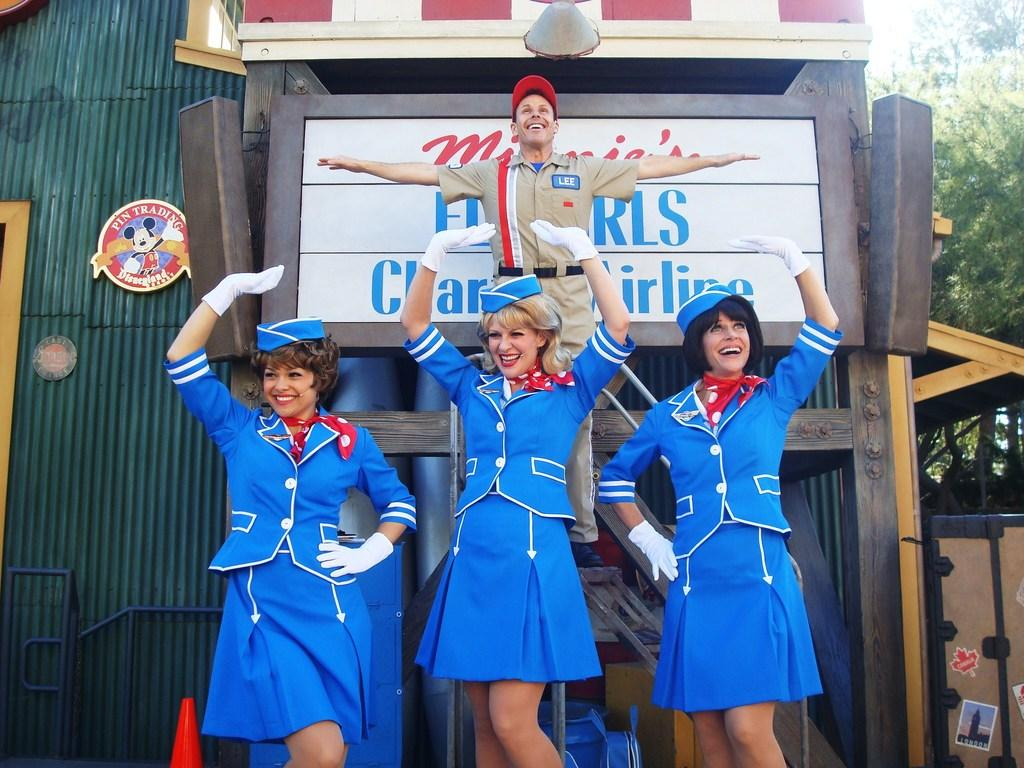<image>
Render a clear and concise summary of the photo. A man wearing a name tag that says Lee is lifted up by women dressed as flight attendants. 